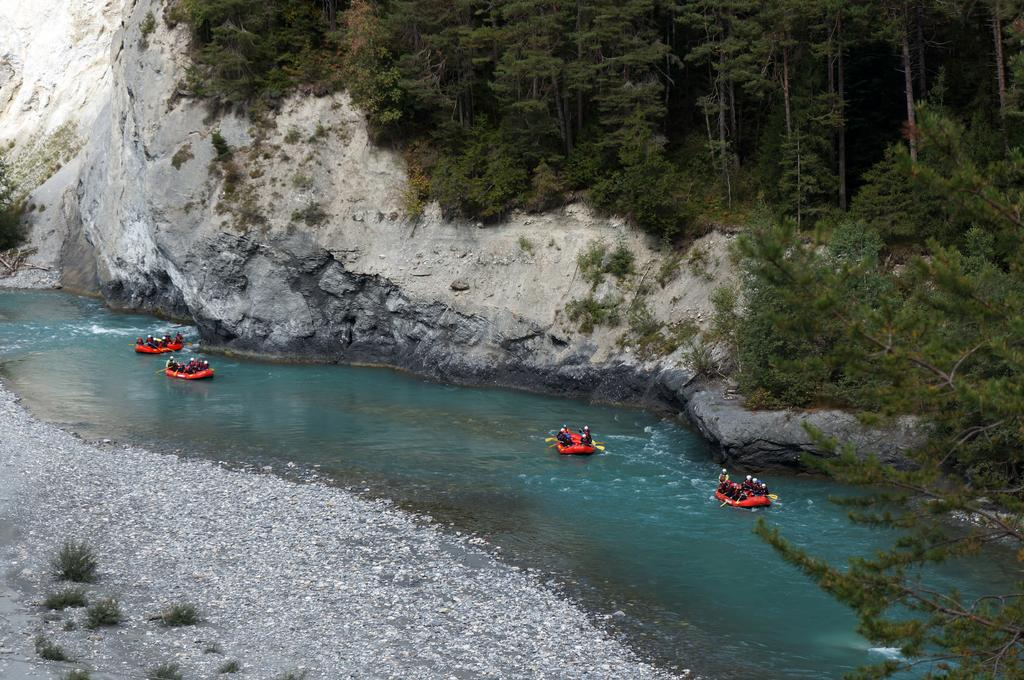What type of natural landscape can be seen in the background of the image? There are mountains and thicket in the background of the image. What are the people in the image doing? The people are sitting in inflatable boats. What objects are visible in the image that might be used for propelling the boats? Paddles are visible in the image. What type of water body is present in the image? There is water in the image. What other natural elements can be seen in the image? Plants are present in the image. What type of gold can be seen in the image? There is no gold present in the image. What type of development can be seen in the image? The image does not show any development or construction; it features people in inflatable boats on a body of water with mountains and thicket in the background. 